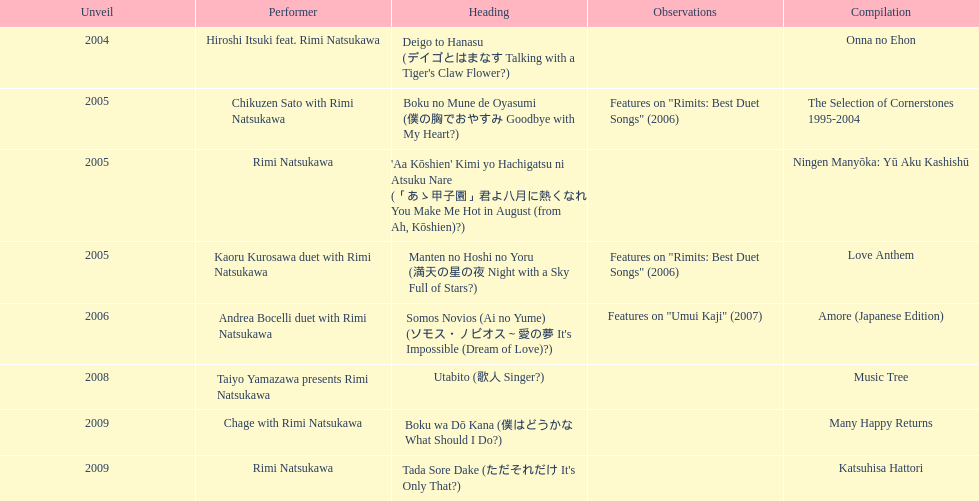What has been the last song this artist has made an other appearance on? Tada Sore Dake. 